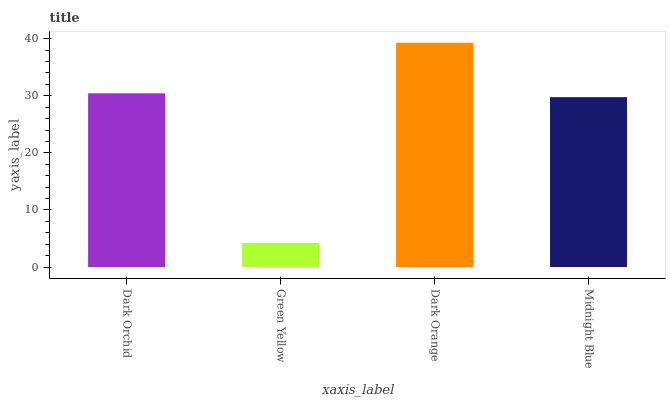Is Green Yellow the minimum?
Answer yes or no. Yes. Is Dark Orange the maximum?
Answer yes or no. Yes. Is Dark Orange the minimum?
Answer yes or no. No. Is Green Yellow the maximum?
Answer yes or no. No. Is Dark Orange greater than Green Yellow?
Answer yes or no. Yes. Is Green Yellow less than Dark Orange?
Answer yes or no. Yes. Is Green Yellow greater than Dark Orange?
Answer yes or no. No. Is Dark Orange less than Green Yellow?
Answer yes or no. No. Is Dark Orchid the high median?
Answer yes or no. Yes. Is Midnight Blue the low median?
Answer yes or no. Yes. Is Midnight Blue the high median?
Answer yes or no. No. Is Green Yellow the low median?
Answer yes or no. No. 